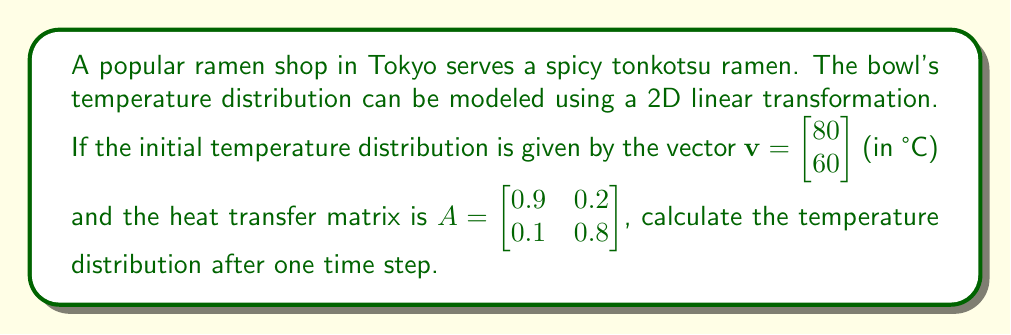Solve this math problem. To solve this problem, we need to apply the linear transformation represented by matrix A to the initial temperature distribution vector v. This can be done using matrix multiplication.

Step 1: Set up the matrix multiplication
$$A\mathbf{v} = \begin{bmatrix} 0.9 & 0.2 \\ 0.1 & 0.8 \end{bmatrix} \begin{bmatrix} 80 \\ 60 \end{bmatrix}$$

Step 2: Perform the matrix multiplication
$$(0.9 \times 80 + 0.2 \times 60) = 72 + 12 = 84$$
$$(0.1 \times 80 + 0.8 \times 60) = 8 + 48 = 56$$

Step 3: Write the result as a vector
$$A\mathbf{v} = \begin{bmatrix} 84 \\ 56 \end{bmatrix}$$

Therefore, after one time step, the new temperature distribution in the ramen bowl is 84°C at the top and 56°C at the bottom.
Answer: $\begin{bmatrix} 84 \\ 56 \end{bmatrix}$ °C 